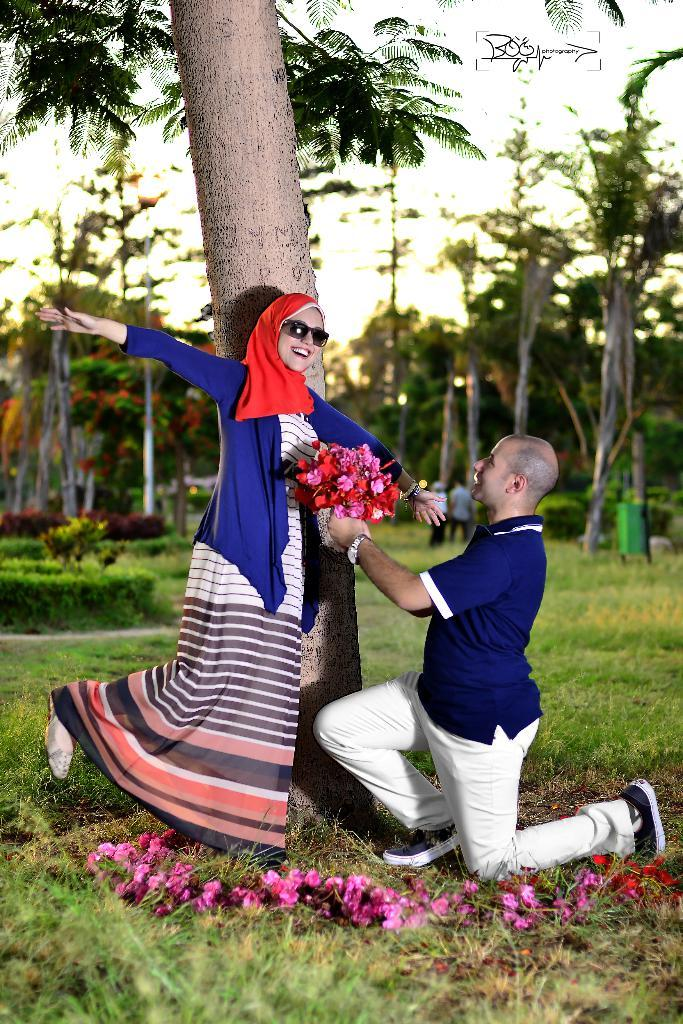Who are the people in the image? There is a woman and a man in the image. What is the man holding in the image? The man is holding a bouquet. What color are the dresses worn by the woman and the man? Both the woman and the man are wearing blue dresses. What can be seen in the background of the image? There are trees in the background of the image. What is the rate of expansion of the scene in the image? The image is a still photograph, so there is no rate of expansion of the scene. 